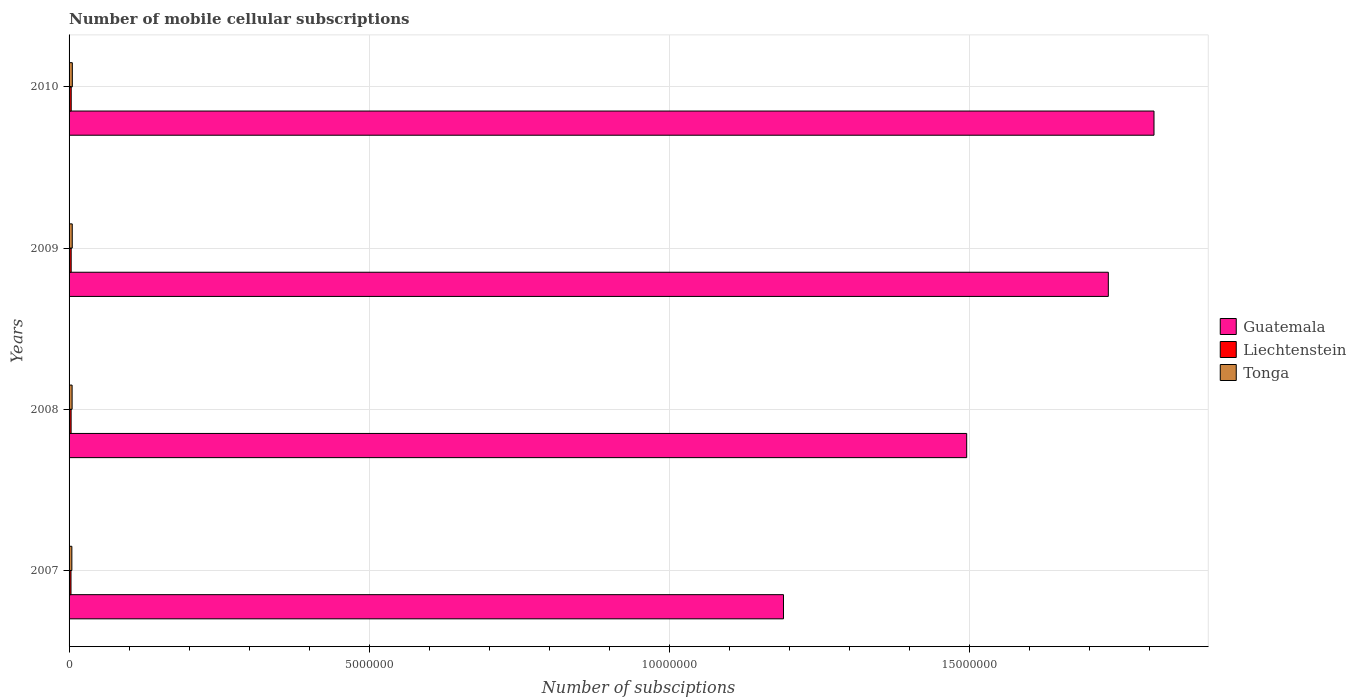How many different coloured bars are there?
Your answer should be very brief. 3. Are the number of bars per tick equal to the number of legend labels?
Make the answer very short. Yes. How many bars are there on the 1st tick from the top?
Give a very brief answer. 3. How many bars are there on the 3rd tick from the bottom?
Make the answer very short. 3. In how many cases, is the number of bars for a given year not equal to the number of legend labels?
Your answer should be very brief. 0. What is the number of mobile cellular subscriptions in Tonga in 2008?
Offer a very short reply. 5.05e+04. Across all years, what is the maximum number of mobile cellular subscriptions in Tonga?
Provide a succinct answer. 5.43e+04. Across all years, what is the minimum number of mobile cellular subscriptions in Liechtenstein?
Provide a short and direct response. 3.20e+04. What is the total number of mobile cellular subscriptions in Liechtenstein in the graph?
Your answer should be compact. 1.37e+05. What is the difference between the number of mobile cellular subscriptions in Liechtenstein in 2009 and that in 2010?
Offer a very short reply. -500. What is the difference between the number of mobile cellular subscriptions in Liechtenstein in 2010 and the number of mobile cellular subscriptions in Guatemala in 2007?
Your answer should be compact. -1.19e+07. What is the average number of mobile cellular subscriptions in Guatemala per year?
Ensure brevity in your answer.  1.56e+07. In the year 2009, what is the difference between the number of mobile cellular subscriptions in Tonga and number of mobile cellular subscriptions in Guatemala?
Offer a terse response. -1.73e+07. What is the ratio of the number of mobile cellular subscriptions in Tonga in 2007 to that in 2009?
Ensure brevity in your answer.  0.88. Is the difference between the number of mobile cellular subscriptions in Tonga in 2009 and 2010 greater than the difference between the number of mobile cellular subscriptions in Guatemala in 2009 and 2010?
Give a very brief answer. Yes. What is the difference between the highest and the second highest number of mobile cellular subscriptions in Guatemala?
Provide a succinct answer. 7.61e+05. What is the difference between the highest and the lowest number of mobile cellular subscriptions in Tonga?
Your answer should be compact. 7775. In how many years, is the number of mobile cellular subscriptions in Tonga greater than the average number of mobile cellular subscriptions in Tonga taken over all years?
Your answer should be compact. 2. What does the 3rd bar from the top in 2009 represents?
Offer a very short reply. Guatemala. What does the 2nd bar from the bottom in 2008 represents?
Provide a succinct answer. Liechtenstein. How many bars are there?
Provide a succinct answer. 12. Are all the bars in the graph horizontal?
Give a very brief answer. Yes. Are the values on the major ticks of X-axis written in scientific E-notation?
Provide a short and direct response. No. Does the graph contain grids?
Your answer should be very brief. Yes. Where does the legend appear in the graph?
Your response must be concise. Center right. What is the title of the graph?
Ensure brevity in your answer.  Number of mobile cellular subscriptions. Does "Switzerland" appear as one of the legend labels in the graph?
Your answer should be compact. No. What is the label or title of the X-axis?
Your answer should be compact. Number of subsciptions. What is the label or title of the Y-axis?
Make the answer very short. Years. What is the Number of subsciptions of Guatemala in 2007?
Ensure brevity in your answer.  1.19e+07. What is the Number of subsciptions of Liechtenstein in 2007?
Ensure brevity in your answer.  3.20e+04. What is the Number of subsciptions in Tonga in 2007?
Provide a short and direct response. 4.65e+04. What is the Number of subsciptions in Guatemala in 2008?
Provide a succinct answer. 1.49e+07. What is the Number of subsciptions of Liechtenstein in 2008?
Your answer should be very brief. 3.40e+04. What is the Number of subsciptions in Tonga in 2008?
Provide a short and direct response. 5.05e+04. What is the Number of subsciptions in Guatemala in 2009?
Provide a succinct answer. 1.73e+07. What is the Number of subsciptions of Liechtenstein in 2009?
Your answer should be very brief. 3.50e+04. What is the Number of subsciptions in Tonga in 2009?
Ensure brevity in your answer.  5.30e+04. What is the Number of subsciptions in Guatemala in 2010?
Ensure brevity in your answer.  1.81e+07. What is the Number of subsciptions of Liechtenstein in 2010?
Provide a succinct answer. 3.55e+04. What is the Number of subsciptions in Tonga in 2010?
Your answer should be compact. 5.43e+04. Across all years, what is the maximum Number of subsciptions in Guatemala?
Provide a short and direct response. 1.81e+07. Across all years, what is the maximum Number of subsciptions of Liechtenstein?
Offer a very short reply. 3.55e+04. Across all years, what is the maximum Number of subsciptions of Tonga?
Provide a succinct answer. 5.43e+04. Across all years, what is the minimum Number of subsciptions in Guatemala?
Offer a terse response. 1.19e+07. Across all years, what is the minimum Number of subsciptions in Liechtenstein?
Ensure brevity in your answer.  3.20e+04. Across all years, what is the minimum Number of subsciptions of Tonga?
Offer a terse response. 4.65e+04. What is the total Number of subsciptions of Guatemala in the graph?
Your response must be concise. 6.22e+07. What is the total Number of subsciptions in Liechtenstein in the graph?
Offer a very short reply. 1.37e+05. What is the total Number of subsciptions of Tonga in the graph?
Your answer should be very brief. 2.04e+05. What is the difference between the Number of subsciptions in Guatemala in 2007 and that in 2008?
Provide a succinct answer. -3.05e+06. What is the difference between the Number of subsciptions in Liechtenstein in 2007 and that in 2008?
Offer a very short reply. -1987. What is the difference between the Number of subsciptions of Tonga in 2007 and that in 2008?
Keep it short and to the point. -3947. What is the difference between the Number of subsciptions of Guatemala in 2007 and that in 2009?
Keep it short and to the point. -5.41e+06. What is the difference between the Number of subsciptions in Liechtenstein in 2007 and that in 2009?
Make the answer very short. -2987. What is the difference between the Number of subsciptions of Tonga in 2007 and that in 2009?
Your answer should be very brief. -6475. What is the difference between the Number of subsciptions in Guatemala in 2007 and that in 2010?
Ensure brevity in your answer.  -6.17e+06. What is the difference between the Number of subsciptions of Liechtenstein in 2007 and that in 2010?
Keep it short and to the point. -3487. What is the difference between the Number of subsciptions of Tonga in 2007 and that in 2010?
Offer a terse response. -7775. What is the difference between the Number of subsciptions of Guatemala in 2008 and that in 2009?
Your response must be concise. -2.36e+06. What is the difference between the Number of subsciptions of Liechtenstein in 2008 and that in 2009?
Your answer should be very brief. -1000. What is the difference between the Number of subsciptions of Tonga in 2008 and that in 2009?
Your answer should be very brief. -2528. What is the difference between the Number of subsciptions of Guatemala in 2008 and that in 2010?
Offer a very short reply. -3.12e+06. What is the difference between the Number of subsciptions of Liechtenstein in 2008 and that in 2010?
Your answer should be very brief. -1500. What is the difference between the Number of subsciptions in Tonga in 2008 and that in 2010?
Make the answer very short. -3828. What is the difference between the Number of subsciptions of Guatemala in 2009 and that in 2010?
Keep it short and to the point. -7.61e+05. What is the difference between the Number of subsciptions in Liechtenstein in 2009 and that in 2010?
Your answer should be compact. -500. What is the difference between the Number of subsciptions of Tonga in 2009 and that in 2010?
Your response must be concise. -1300. What is the difference between the Number of subsciptions of Guatemala in 2007 and the Number of subsciptions of Liechtenstein in 2008?
Your answer should be compact. 1.19e+07. What is the difference between the Number of subsciptions of Guatemala in 2007 and the Number of subsciptions of Tonga in 2008?
Your response must be concise. 1.18e+07. What is the difference between the Number of subsciptions in Liechtenstein in 2007 and the Number of subsciptions in Tonga in 2008?
Offer a terse response. -1.85e+04. What is the difference between the Number of subsciptions of Guatemala in 2007 and the Number of subsciptions of Liechtenstein in 2009?
Your answer should be compact. 1.19e+07. What is the difference between the Number of subsciptions in Guatemala in 2007 and the Number of subsciptions in Tonga in 2009?
Your answer should be very brief. 1.18e+07. What is the difference between the Number of subsciptions of Liechtenstein in 2007 and the Number of subsciptions of Tonga in 2009?
Keep it short and to the point. -2.10e+04. What is the difference between the Number of subsciptions of Guatemala in 2007 and the Number of subsciptions of Liechtenstein in 2010?
Make the answer very short. 1.19e+07. What is the difference between the Number of subsciptions of Guatemala in 2007 and the Number of subsciptions of Tonga in 2010?
Your response must be concise. 1.18e+07. What is the difference between the Number of subsciptions in Liechtenstein in 2007 and the Number of subsciptions in Tonga in 2010?
Give a very brief answer. -2.23e+04. What is the difference between the Number of subsciptions in Guatemala in 2008 and the Number of subsciptions in Liechtenstein in 2009?
Give a very brief answer. 1.49e+07. What is the difference between the Number of subsciptions of Guatemala in 2008 and the Number of subsciptions of Tonga in 2009?
Offer a very short reply. 1.49e+07. What is the difference between the Number of subsciptions in Liechtenstein in 2008 and the Number of subsciptions in Tonga in 2009?
Provide a succinct answer. -1.90e+04. What is the difference between the Number of subsciptions of Guatemala in 2008 and the Number of subsciptions of Liechtenstein in 2010?
Offer a very short reply. 1.49e+07. What is the difference between the Number of subsciptions of Guatemala in 2008 and the Number of subsciptions of Tonga in 2010?
Ensure brevity in your answer.  1.49e+07. What is the difference between the Number of subsciptions in Liechtenstein in 2008 and the Number of subsciptions in Tonga in 2010?
Your answer should be compact. -2.03e+04. What is the difference between the Number of subsciptions in Guatemala in 2009 and the Number of subsciptions in Liechtenstein in 2010?
Make the answer very short. 1.73e+07. What is the difference between the Number of subsciptions of Guatemala in 2009 and the Number of subsciptions of Tonga in 2010?
Offer a very short reply. 1.73e+07. What is the difference between the Number of subsciptions of Liechtenstein in 2009 and the Number of subsciptions of Tonga in 2010?
Offer a terse response. -1.93e+04. What is the average Number of subsciptions of Guatemala per year?
Provide a short and direct response. 1.56e+07. What is the average Number of subsciptions in Liechtenstein per year?
Your answer should be very brief. 3.41e+04. What is the average Number of subsciptions in Tonga per year?
Give a very brief answer. 5.11e+04. In the year 2007, what is the difference between the Number of subsciptions of Guatemala and Number of subsciptions of Liechtenstein?
Offer a terse response. 1.19e+07. In the year 2007, what is the difference between the Number of subsciptions in Guatemala and Number of subsciptions in Tonga?
Keep it short and to the point. 1.19e+07. In the year 2007, what is the difference between the Number of subsciptions of Liechtenstein and Number of subsciptions of Tonga?
Make the answer very short. -1.45e+04. In the year 2008, what is the difference between the Number of subsciptions of Guatemala and Number of subsciptions of Liechtenstein?
Give a very brief answer. 1.49e+07. In the year 2008, what is the difference between the Number of subsciptions in Guatemala and Number of subsciptions in Tonga?
Ensure brevity in your answer.  1.49e+07. In the year 2008, what is the difference between the Number of subsciptions of Liechtenstein and Number of subsciptions of Tonga?
Your answer should be compact. -1.65e+04. In the year 2009, what is the difference between the Number of subsciptions in Guatemala and Number of subsciptions in Liechtenstein?
Ensure brevity in your answer.  1.73e+07. In the year 2009, what is the difference between the Number of subsciptions in Guatemala and Number of subsciptions in Tonga?
Offer a very short reply. 1.73e+07. In the year 2009, what is the difference between the Number of subsciptions of Liechtenstein and Number of subsciptions of Tonga?
Provide a succinct answer. -1.80e+04. In the year 2010, what is the difference between the Number of subsciptions in Guatemala and Number of subsciptions in Liechtenstein?
Provide a short and direct response. 1.80e+07. In the year 2010, what is the difference between the Number of subsciptions of Guatemala and Number of subsciptions of Tonga?
Keep it short and to the point. 1.80e+07. In the year 2010, what is the difference between the Number of subsciptions in Liechtenstein and Number of subsciptions in Tonga?
Provide a succinct answer. -1.88e+04. What is the ratio of the Number of subsciptions of Guatemala in 2007 to that in 2008?
Ensure brevity in your answer.  0.8. What is the ratio of the Number of subsciptions of Liechtenstein in 2007 to that in 2008?
Offer a terse response. 0.94. What is the ratio of the Number of subsciptions of Tonga in 2007 to that in 2008?
Give a very brief answer. 0.92. What is the ratio of the Number of subsciptions in Guatemala in 2007 to that in 2009?
Offer a very short reply. 0.69. What is the ratio of the Number of subsciptions in Liechtenstein in 2007 to that in 2009?
Ensure brevity in your answer.  0.91. What is the ratio of the Number of subsciptions in Tonga in 2007 to that in 2009?
Your answer should be compact. 0.88. What is the ratio of the Number of subsciptions of Guatemala in 2007 to that in 2010?
Make the answer very short. 0.66. What is the ratio of the Number of subsciptions of Liechtenstein in 2007 to that in 2010?
Offer a very short reply. 0.9. What is the ratio of the Number of subsciptions in Tonga in 2007 to that in 2010?
Provide a short and direct response. 0.86. What is the ratio of the Number of subsciptions of Guatemala in 2008 to that in 2009?
Your response must be concise. 0.86. What is the ratio of the Number of subsciptions of Liechtenstein in 2008 to that in 2009?
Make the answer very short. 0.97. What is the ratio of the Number of subsciptions in Tonga in 2008 to that in 2009?
Provide a succinct answer. 0.95. What is the ratio of the Number of subsciptions of Guatemala in 2008 to that in 2010?
Your response must be concise. 0.83. What is the ratio of the Number of subsciptions of Liechtenstein in 2008 to that in 2010?
Ensure brevity in your answer.  0.96. What is the ratio of the Number of subsciptions of Tonga in 2008 to that in 2010?
Your response must be concise. 0.93. What is the ratio of the Number of subsciptions in Guatemala in 2009 to that in 2010?
Ensure brevity in your answer.  0.96. What is the ratio of the Number of subsciptions in Liechtenstein in 2009 to that in 2010?
Your answer should be compact. 0.99. What is the ratio of the Number of subsciptions in Tonga in 2009 to that in 2010?
Provide a succinct answer. 0.98. What is the difference between the highest and the second highest Number of subsciptions of Guatemala?
Provide a succinct answer. 7.61e+05. What is the difference between the highest and the second highest Number of subsciptions of Tonga?
Your answer should be very brief. 1300. What is the difference between the highest and the lowest Number of subsciptions of Guatemala?
Your answer should be very brief. 6.17e+06. What is the difference between the highest and the lowest Number of subsciptions of Liechtenstein?
Provide a short and direct response. 3487. What is the difference between the highest and the lowest Number of subsciptions in Tonga?
Offer a terse response. 7775. 